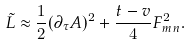<formula> <loc_0><loc_0><loc_500><loc_500>\tilde { L } \approx \frac { 1 } { 2 } ( \partial _ { \tau } { A } ) ^ { 2 } + \frac { t - v } { 4 } F _ { m n } ^ { 2 } .</formula> 